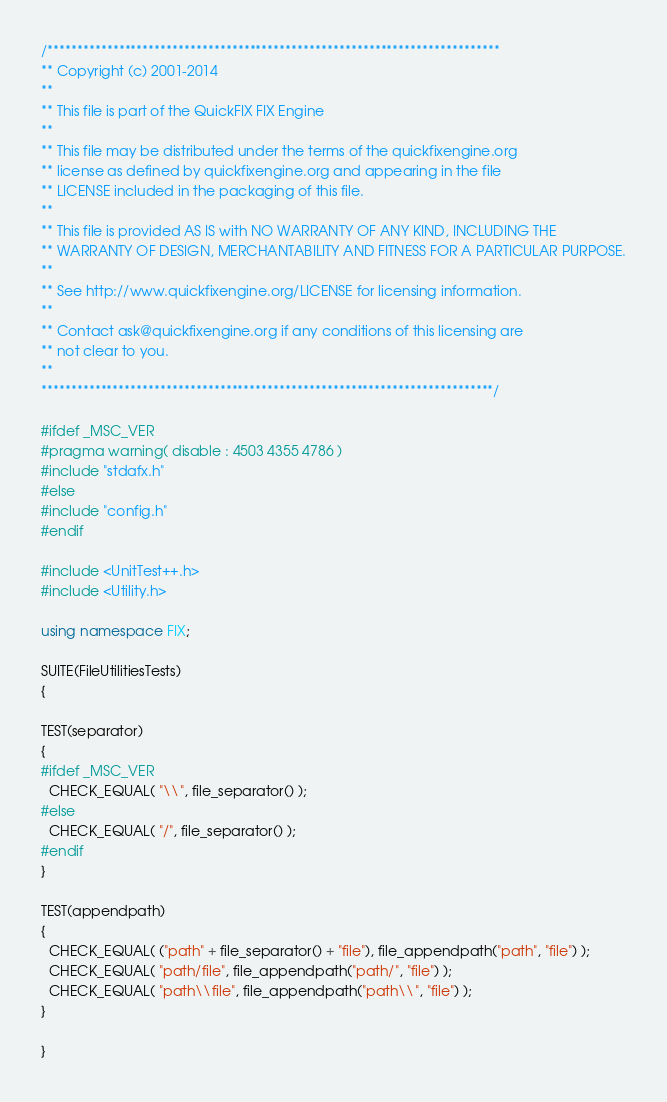<code> <loc_0><loc_0><loc_500><loc_500><_C++_>/****************************************************************************
** Copyright (c) 2001-2014
**
** This file is part of the QuickFIX FIX Engine
**
** This file may be distributed under the terms of the quickfixengine.org
** license as defined by quickfixengine.org and appearing in the file
** LICENSE included in the packaging of this file.
**
** This file is provided AS IS with NO WARRANTY OF ANY KIND, INCLUDING THE
** WARRANTY OF DESIGN, MERCHANTABILITY AND FITNESS FOR A PARTICULAR PURPOSE.
**
** See http://www.quickfixengine.org/LICENSE for licensing information.
**
** Contact ask@quickfixengine.org if any conditions of this licensing are
** not clear to you.
**
****************************************************************************/

#ifdef _MSC_VER
#pragma warning( disable : 4503 4355 4786 )
#include "stdafx.h"
#else
#include "config.h"
#endif

#include <UnitTest++.h>
#include <Utility.h>

using namespace FIX;

SUITE(FileUtilitiesTests)
{

TEST(separator)
{
#ifdef _MSC_VER
  CHECK_EQUAL( "\\", file_separator() );
#else
  CHECK_EQUAL( "/", file_separator() );
#endif
}

TEST(appendpath)
{
  CHECK_EQUAL( ("path" + file_separator() + "file"), file_appendpath("path", "file") );
  CHECK_EQUAL( "path/file", file_appendpath("path/", "file") );
  CHECK_EQUAL( "path\\file", file_appendpath("path\\", "file") );
}

}
</code> 